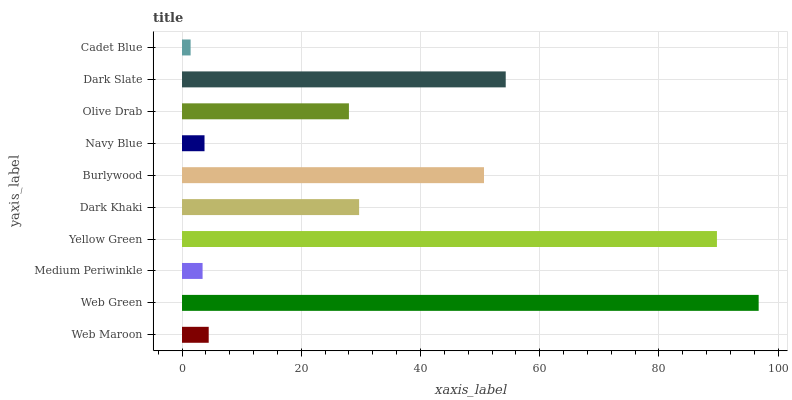Is Cadet Blue the minimum?
Answer yes or no. Yes. Is Web Green the maximum?
Answer yes or no. Yes. Is Medium Periwinkle the minimum?
Answer yes or no. No. Is Medium Periwinkle the maximum?
Answer yes or no. No. Is Web Green greater than Medium Periwinkle?
Answer yes or no. Yes. Is Medium Periwinkle less than Web Green?
Answer yes or no. Yes. Is Medium Periwinkle greater than Web Green?
Answer yes or no. No. Is Web Green less than Medium Periwinkle?
Answer yes or no. No. Is Dark Khaki the high median?
Answer yes or no. Yes. Is Olive Drab the low median?
Answer yes or no. Yes. Is Web Green the high median?
Answer yes or no. No. Is Cadet Blue the low median?
Answer yes or no. No. 